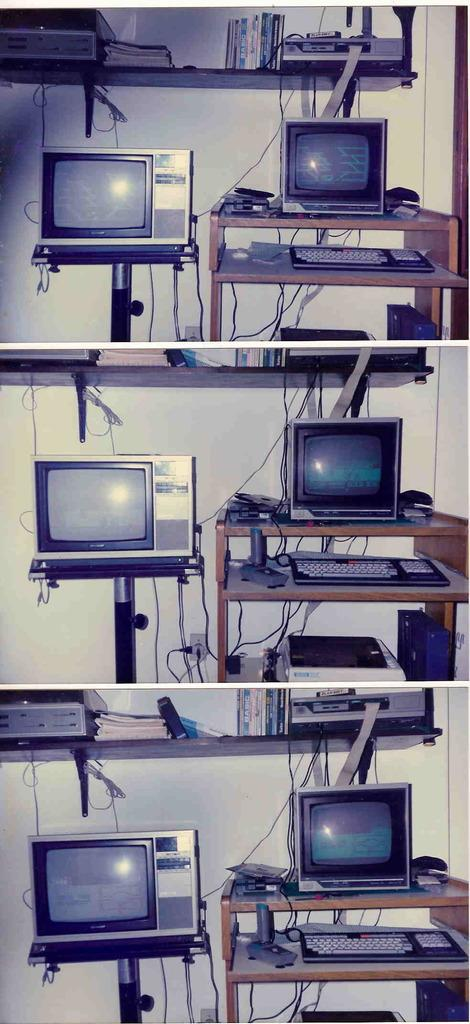What electronic devices are present in the image? There are televisions in the image. What piece of furniture can be seen in the image? There is a table in the image. What is the color of the table? The table is brown. What color is the background wall in the image? The background wall is white. What type of flesh can be seen in the image? There is no flesh present in the image. 